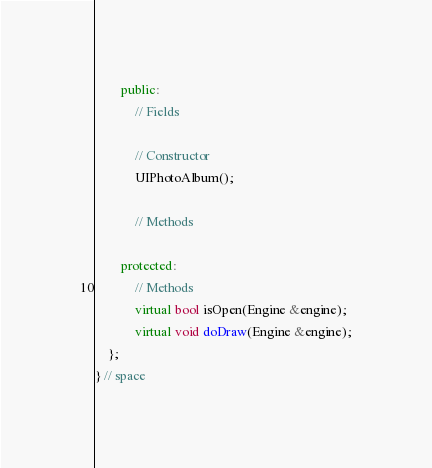Convert code to text. <code><loc_0><loc_0><loc_500><loc_500><_C++_>        public:
            // Fields

            // Constructor
            UIPhotoAlbum();

            // Methods

        protected:
            // Methods
            virtual bool isOpen(Engine &engine);
            virtual void doDraw(Engine &engine);
    };
} // space</code> 